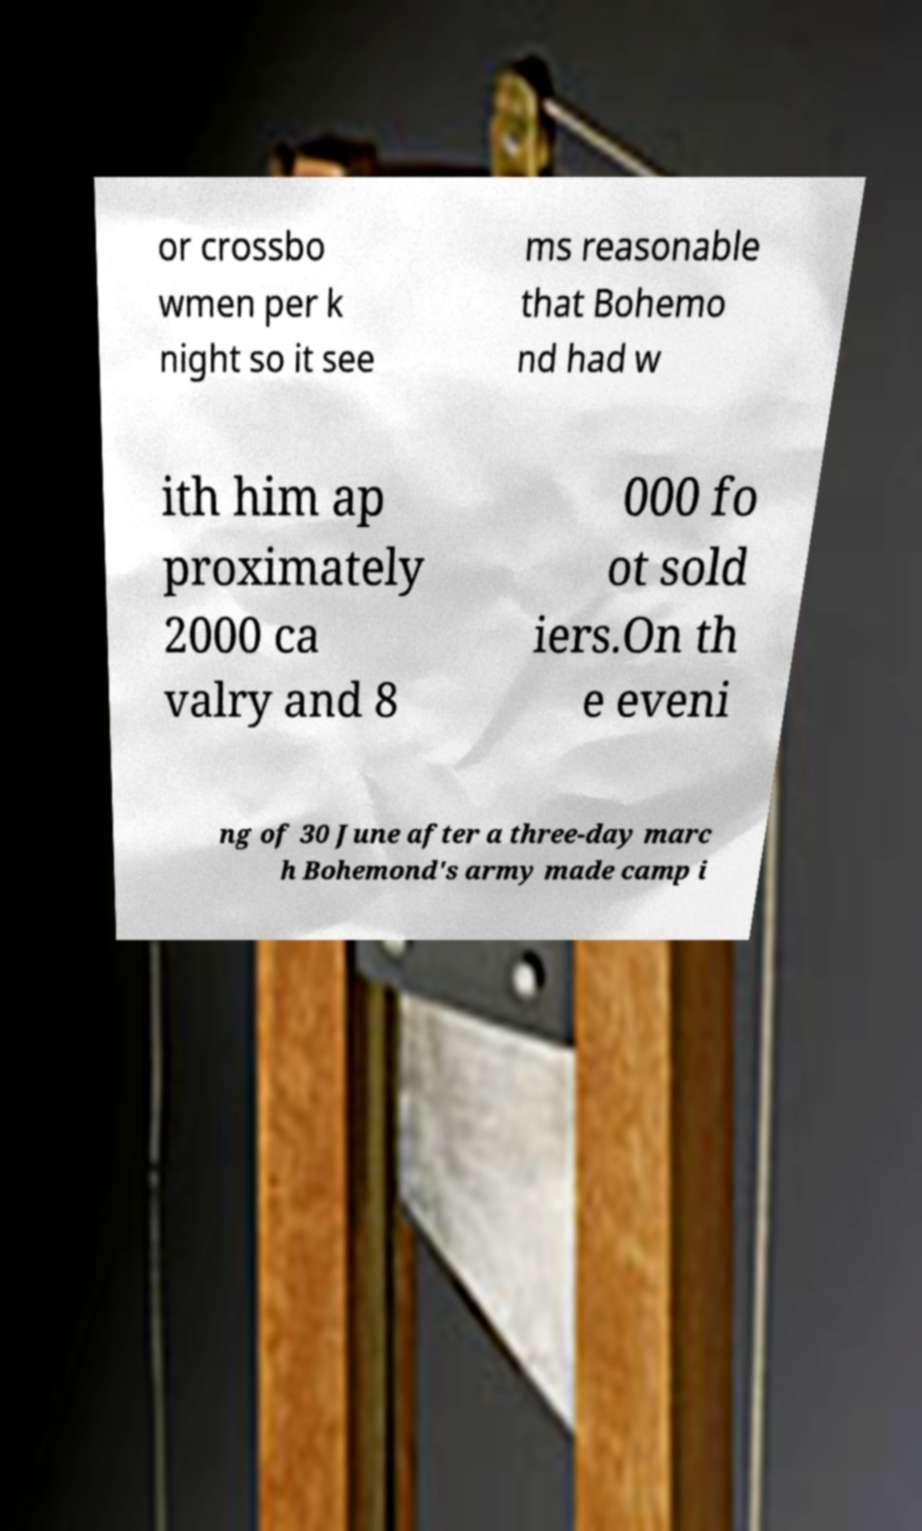I need the written content from this picture converted into text. Can you do that? or crossbo wmen per k night so it see ms reasonable that Bohemo nd had w ith him ap proximately 2000 ca valry and 8 000 fo ot sold iers.On th e eveni ng of 30 June after a three-day marc h Bohemond's army made camp i 